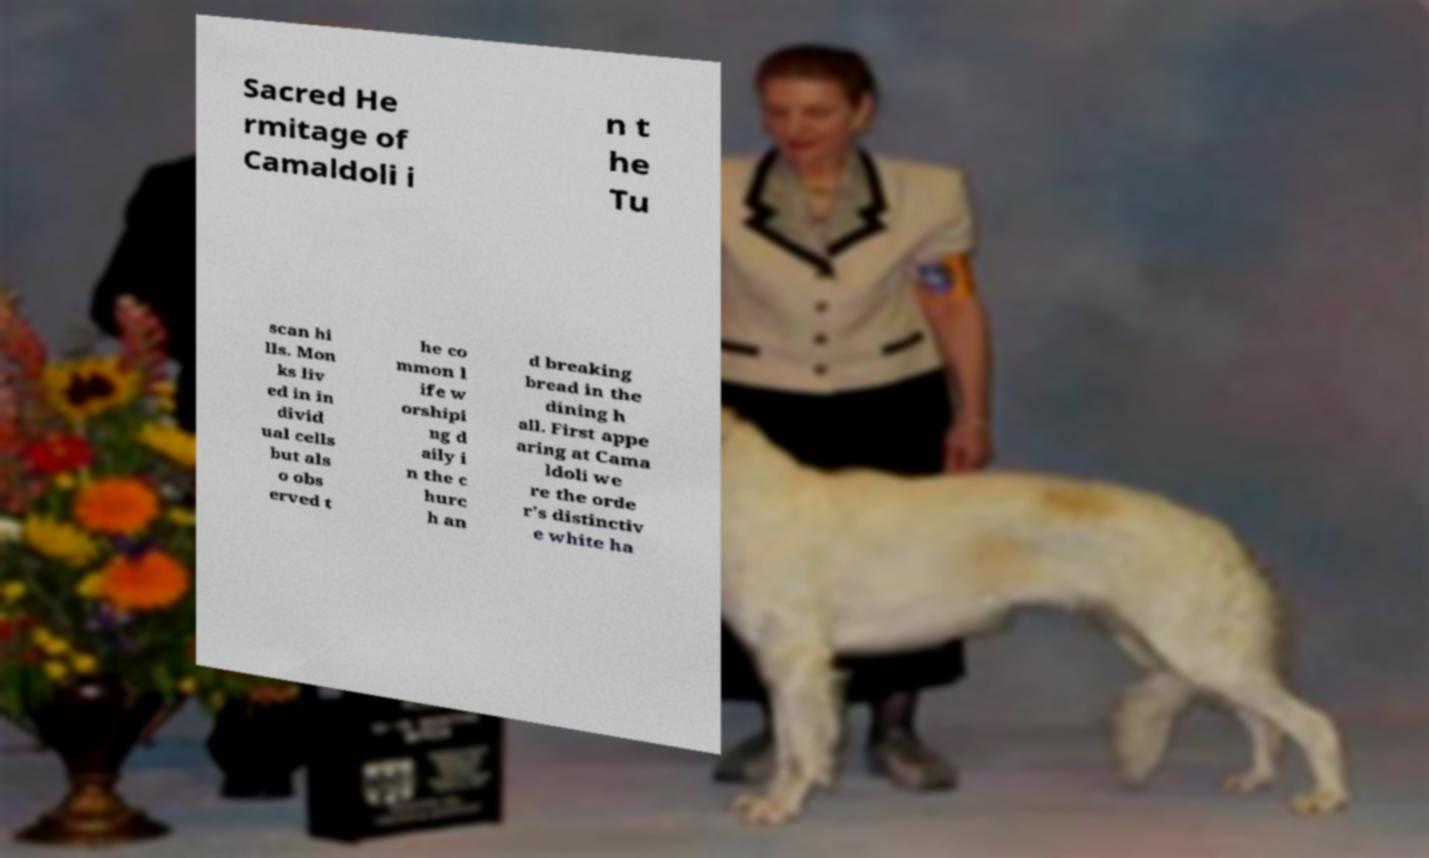For documentation purposes, I need the text within this image transcribed. Could you provide that? Sacred He rmitage of Camaldoli i n t he Tu scan hi lls. Mon ks liv ed in in divid ual cells but als o obs erved t he co mmon l ife w orshipi ng d aily i n the c hurc h an d breaking bread in the dining h all. First appe aring at Cama ldoli we re the orde r's distinctiv e white ha 